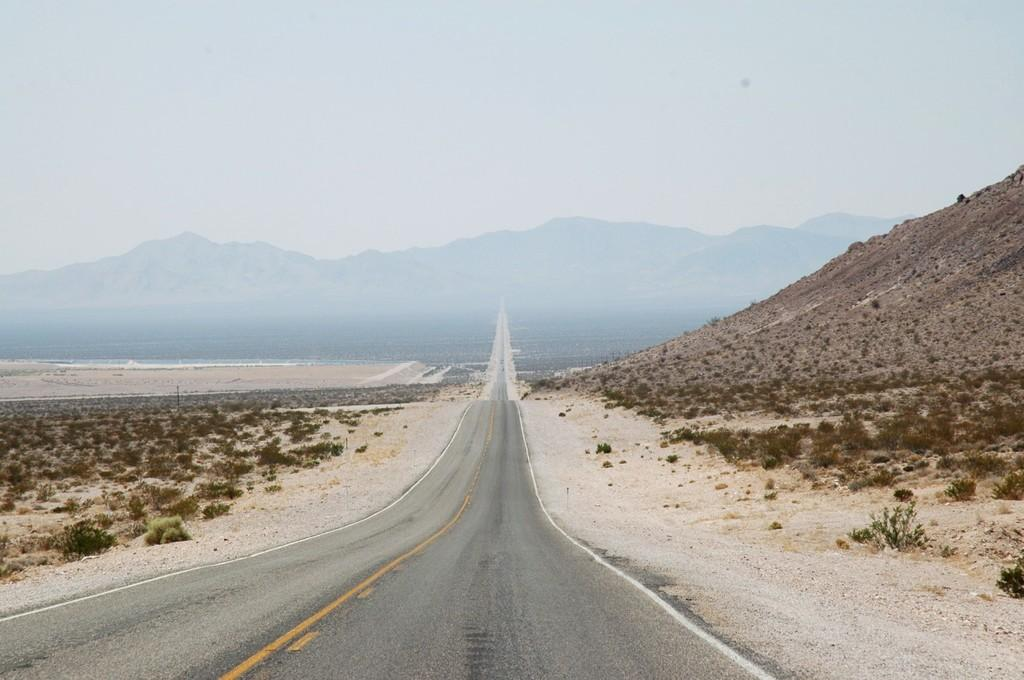What is the main feature of the image? There is a road in the image. What can be seen on the ground on both sides of the road? There are small plants on the ground on both sides of the road. What is visible in the background of the image? There is a mountain in the background of the image. What is visible at the top of the image? The sky is visible at the top of the image. How many toys can be seen scattered on the road in the image? There are no toys present in the image. 